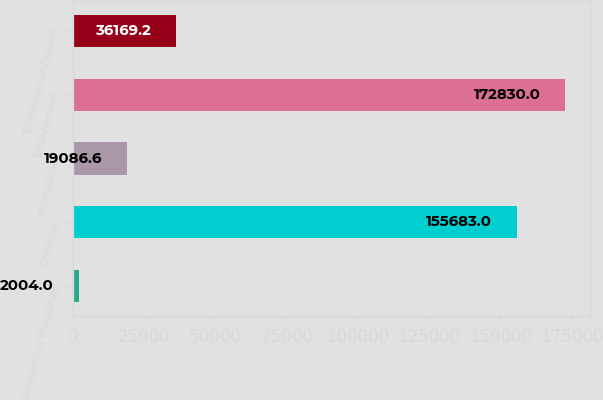<chart> <loc_0><loc_0><loc_500><loc_500><bar_chart><fcel>(Amounts in thousands)<fcel>Domestic<fcel>International<fcel>Totalrevenues<fcel>Total long-lived assets<nl><fcel>2004<fcel>155683<fcel>19086.6<fcel>172830<fcel>36169.2<nl></chart> 